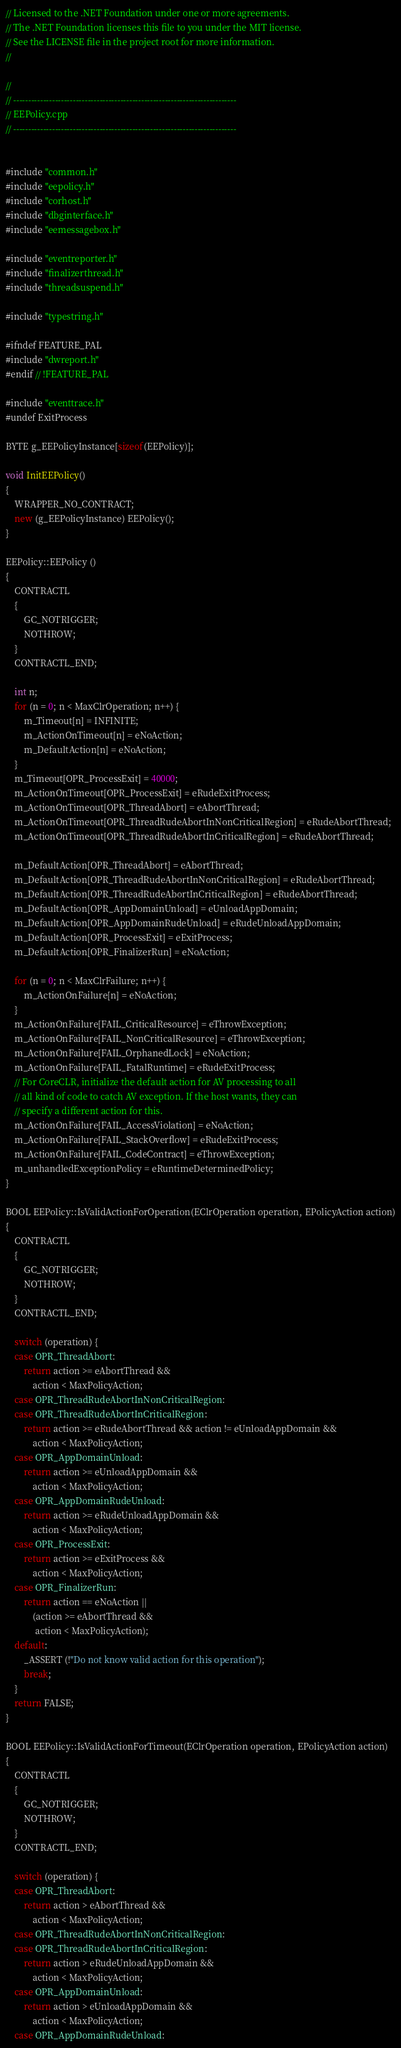Convert code to text. <code><loc_0><loc_0><loc_500><loc_500><_C++_>// Licensed to the .NET Foundation under one or more agreements.
// The .NET Foundation licenses this file to you under the MIT license.
// See the LICENSE file in the project root for more information.
//

//
// ---------------------------------------------------------------------------
// EEPolicy.cpp
// ---------------------------------------------------------------------------


#include "common.h"
#include "eepolicy.h"
#include "corhost.h"
#include "dbginterface.h"
#include "eemessagebox.h"

#include "eventreporter.h"
#include "finalizerthread.h"
#include "threadsuspend.h"

#include "typestring.h"

#ifndef FEATURE_PAL
#include "dwreport.h"
#endif // !FEATURE_PAL

#include "eventtrace.h"
#undef ExitProcess

BYTE g_EEPolicyInstance[sizeof(EEPolicy)];

void InitEEPolicy()
{
    WRAPPER_NO_CONTRACT;
    new (g_EEPolicyInstance) EEPolicy();
}

EEPolicy::EEPolicy ()
{
    CONTRACTL
    {
        GC_NOTRIGGER;
        NOTHROW;
    }
    CONTRACTL_END;
    
    int n;
    for (n = 0; n < MaxClrOperation; n++) {
        m_Timeout[n] = INFINITE;
        m_ActionOnTimeout[n] = eNoAction;
        m_DefaultAction[n] = eNoAction;
    }
    m_Timeout[OPR_ProcessExit] = 40000;
    m_ActionOnTimeout[OPR_ProcessExit] = eRudeExitProcess;
    m_ActionOnTimeout[OPR_ThreadAbort] = eAbortThread;
    m_ActionOnTimeout[OPR_ThreadRudeAbortInNonCriticalRegion] = eRudeAbortThread;
    m_ActionOnTimeout[OPR_ThreadRudeAbortInCriticalRegion] = eRudeAbortThread;

    m_DefaultAction[OPR_ThreadAbort] = eAbortThread;
    m_DefaultAction[OPR_ThreadRudeAbortInNonCriticalRegion] = eRudeAbortThread;
    m_DefaultAction[OPR_ThreadRudeAbortInCriticalRegion] = eRudeAbortThread;
    m_DefaultAction[OPR_AppDomainUnload] = eUnloadAppDomain;
    m_DefaultAction[OPR_AppDomainRudeUnload] = eRudeUnloadAppDomain;
    m_DefaultAction[OPR_ProcessExit] = eExitProcess;
    m_DefaultAction[OPR_FinalizerRun] = eNoAction;

    for (n = 0; n < MaxClrFailure; n++) {
        m_ActionOnFailure[n] = eNoAction;
    }
    m_ActionOnFailure[FAIL_CriticalResource] = eThrowException;
    m_ActionOnFailure[FAIL_NonCriticalResource] = eThrowException;
    m_ActionOnFailure[FAIL_OrphanedLock] = eNoAction;
    m_ActionOnFailure[FAIL_FatalRuntime] = eRudeExitProcess;
    // For CoreCLR, initialize the default action for AV processing to all
    // all kind of code to catch AV exception. If the host wants, they can
    // specify a different action for this.
    m_ActionOnFailure[FAIL_AccessViolation] = eNoAction;
    m_ActionOnFailure[FAIL_StackOverflow] = eRudeExitProcess;
    m_ActionOnFailure[FAIL_CodeContract] = eThrowException;
    m_unhandledExceptionPolicy = eRuntimeDeterminedPolicy;
}

BOOL EEPolicy::IsValidActionForOperation(EClrOperation operation, EPolicyAction action)
{
    CONTRACTL
    {
        GC_NOTRIGGER;
        NOTHROW;
    }
    CONTRACTL_END;
    
    switch (operation) {
    case OPR_ThreadAbort:
        return action >= eAbortThread &&
            action < MaxPolicyAction;
    case OPR_ThreadRudeAbortInNonCriticalRegion:
    case OPR_ThreadRudeAbortInCriticalRegion:
        return action >= eRudeAbortThread && action != eUnloadAppDomain &&
            action < MaxPolicyAction;
    case OPR_AppDomainUnload:
        return action >= eUnloadAppDomain &&
            action < MaxPolicyAction;
    case OPR_AppDomainRudeUnload:
        return action >= eRudeUnloadAppDomain &&
            action < MaxPolicyAction;
    case OPR_ProcessExit:
        return action >= eExitProcess &&
            action < MaxPolicyAction;
    case OPR_FinalizerRun:
        return action == eNoAction ||
            (action >= eAbortThread &&
             action < MaxPolicyAction);
    default:
        _ASSERT (!"Do not know valid action for this operation");
        break;
    }
    return FALSE;
}

BOOL EEPolicy::IsValidActionForTimeout(EClrOperation operation, EPolicyAction action)
{
    CONTRACTL
    {
        GC_NOTRIGGER;
        NOTHROW;
    }
    CONTRACTL_END;
    
    switch (operation) {
    case OPR_ThreadAbort:
        return action > eAbortThread &&
            action < MaxPolicyAction;
    case OPR_ThreadRudeAbortInNonCriticalRegion:
    case OPR_ThreadRudeAbortInCriticalRegion:
        return action > eRudeUnloadAppDomain &&
            action < MaxPolicyAction;
    case OPR_AppDomainUnload:
        return action > eUnloadAppDomain &&
            action < MaxPolicyAction;
    case OPR_AppDomainRudeUnload:</code> 